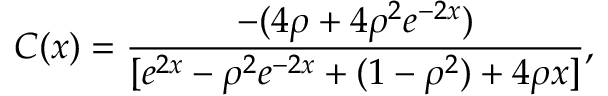<formula> <loc_0><loc_0><loc_500><loc_500>C ( x ) = \frac { - ( 4 \rho + 4 \rho ^ { 2 } e ^ { - 2 x } ) } { [ e ^ { 2 x } - \rho ^ { 2 } e ^ { - 2 x } + ( 1 - \rho ^ { 2 } ) + 4 \rho x ] } ,</formula> 